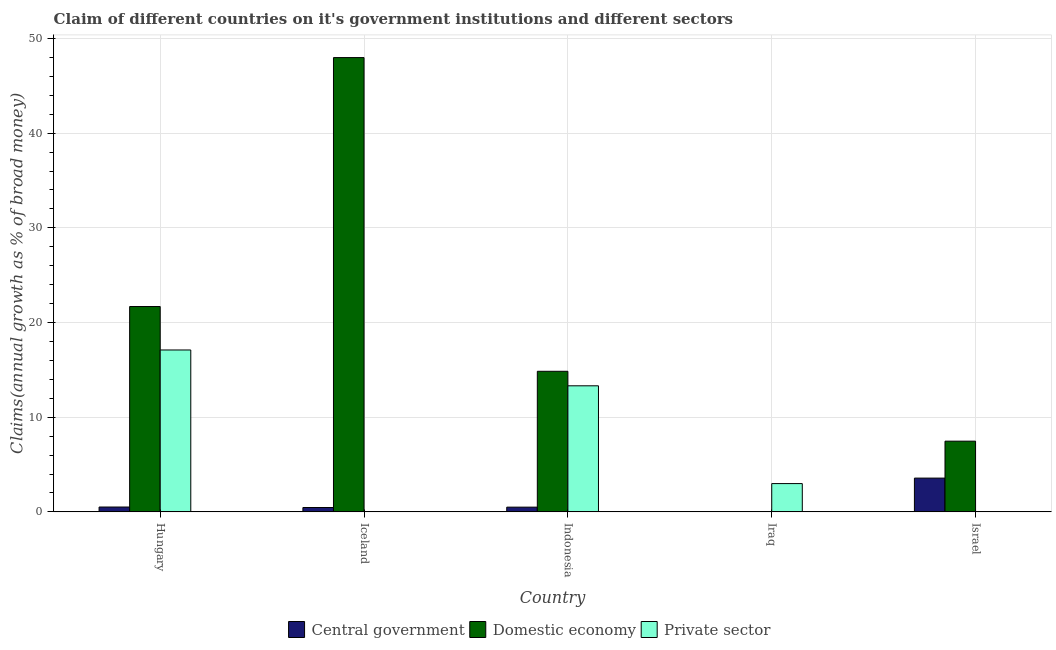How many different coloured bars are there?
Your response must be concise. 3. How many bars are there on the 1st tick from the left?
Your response must be concise. 3. How many bars are there on the 5th tick from the right?
Make the answer very short. 3. What is the label of the 1st group of bars from the left?
Make the answer very short. Hungary. What is the percentage of claim on the private sector in Israel?
Keep it short and to the point. 0. Across all countries, what is the maximum percentage of claim on the domestic economy?
Your answer should be very brief. 47.98. What is the total percentage of claim on the private sector in the graph?
Offer a very short reply. 33.4. What is the difference between the percentage of claim on the private sector in Hungary and that in Iraq?
Your answer should be compact. 14.11. What is the difference between the percentage of claim on the central government in Israel and the percentage of claim on the private sector in Iraq?
Offer a terse response. 0.58. What is the average percentage of claim on the central government per country?
Keep it short and to the point. 1.01. What is the difference between the percentage of claim on the private sector and percentage of claim on the central government in Indonesia?
Your response must be concise. 12.82. What is the ratio of the percentage of claim on the private sector in Indonesia to that in Iraq?
Make the answer very short. 4.46. What is the difference between the highest and the second highest percentage of claim on the central government?
Your response must be concise. 3.05. What is the difference between the highest and the lowest percentage of claim on the domestic economy?
Provide a succinct answer. 47.98. Is it the case that in every country, the sum of the percentage of claim on the central government and percentage of claim on the domestic economy is greater than the percentage of claim on the private sector?
Make the answer very short. No. How many bars are there?
Make the answer very short. 11. What is the difference between two consecutive major ticks on the Y-axis?
Offer a terse response. 10. Does the graph contain any zero values?
Offer a very short reply. Yes. Does the graph contain grids?
Make the answer very short. Yes. Where does the legend appear in the graph?
Offer a terse response. Bottom center. How many legend labels are there?
Provide a succinct answer. 3. What is the title of the graph?
Offer a terse response. Claim of different countries on it's government institutions and different sectors. What is the label or title of the Y-axis?
Provide a succinct answer. Claims(annual growth as % of broad money). What is the Claims(annual growth as % of broad money) in Central government in Hungary?
Offer a very short reply. 0.51. What is the Claims(annual growth as % of broad money) in Domestic economy in Hungary?
Your answer should be very brief. 21.69. What is the Claims(annual growth as % of broad money) in Private sector in Hungary?
Offer a terse response. 17.1. What is the Claims(annual growth as % of broad money) in Central government in Iceland?
Keep it short and to the point. 0.46. What is the Claims(annual growth as % of broad money) in Domestic economy in Iceland?
Your response must be concise. 47.98. What is the Claims(annual growth as % of broad money) in Central government in Indonesia?
Your answer should be compact. 0.5. What is the Claims(annual growth as % of broad money) in Domestic economy in Indonesia?
Your response must be concise. 14.85. What is the Claims(annual growth as % of broad money) of Private sector in Indonesia?
Offer a very short reply. 13.32. What is the Claims(annual growth as % of broad money) of Central government in Iraq?
Provide a succinct answer. 0. What is the Claims(annual growth as % of broad money) in Domestic economy in Iraq?
Make the answer very short. 0. What is the Claims(annual growth as % of broad money) in Private sector in Iraq?
Offer a terse response. 2.99. What is the Claims(annual growth as % of broad money) in Central government in Israel?
Offer a very short reply. 3.57. What is the Claims(annual growth as % of broad money) in Domestic economy in Israel?
Offer a terse response. 7.47. Across all countries, what is the maximum Claims(annual growth as % of broad money) in Central government?
Offer a very short reply. 3.57. Across all countries, what is the maximum Claims(annual growth as % of broad money) in Domestic economy?
Offer a terse response. 47.98. Across all countries, what is the maximum Claims(annual growth as % of broad money) in Private sector?
Provide a succinct answer. 17.1. Across all countries, what is the minimum Claims(annual growth as % of broad money) of Central government?
Provide a short and direct response. 0. What is the total Claims(annual growth as % of broad money) of Central government in the graph?
Offer a terse response. 5.04. What is the total Claims(annual growth as % of broad money) of Domestic economy in the graph?
Provide a succinct answer. 91.99. What is the total Claims(annual growth as % of broad money) in Private sector in the graph?
Ensure brevity in your answer.  33.4. What is the difference between the Claims(annual growth as % of broad money) in Central government in Hungary and that in Iceland?
Make the answer very short. 0.05. What is the difference between the Claims(annual growth as % of broad money) of Domestic economy in Hungary and that in Iceland?
Your answer should be compact. -26.29. What is the difference between the Claims(annual growth as % of broad money) in Central government in Hungary and that in Indonesia?
Provide a short and direct response. 0.01. What is the difference between the Claims(annual growth as % of broad money) in Domestic economy in Hungary and that in Indonesia?
Your answer should be compact. 6.84. What is the difference between the Claims(annual growth as % of broad money) in Private sector in Hungary and that in Indonesia?
Keep it short and to the point. 3.78. What is the difference between the Claims(annual growth as % of broad money) of Private sector in Hungary and that in Iraq?
Your answer should be very brief. 14.11. What is the difference between the Claims(annual growth as % of broad money) in Central government in Hungary and that in Israel?
Ensure brevity in your answer.  -3.05. What is the difference between the Claims(annual growth as % of broad money) in Domestic economy in Hungary and that in Israel?
Make the answer very short. 14.22. What is the difference between the Claims(annual growth as % of broad money) of Central government in Iceland and that in Indonesia?
Your answer should be very brief. -0.04. What is the difference between the Claims(annual growth as % of broad money) of Domestic economy in Iceland and that in Indonesia?
Make the answer very short. 33.13. What is the difference between the Claims(annual growth as % of broad money) in Central government in Iceland and that in Israel?
Offer a very short reply. -3.11. What is the difference between the Claims(annual growth as % of broad money) in Domestic economy in Iceland and that in Israel?
Make the answer very short. 40.51. What is the difference between the Claims(annual growth as % of broad money) in Private sector in Indonesia and that in Iraq?
Give a very brief answer. 10.33. What is the difference between the Claims(annual growth as % of broad money) in Central government in Indonesia and that in Israel?
Ensure brevity in your answer.  -3.07. What is the difference between the Claims(annual growth as % of broad money) in Domestic economy in Indonesia and that in Israel?
Give a very brief answer. 7.38. What is the difference between the Claims(annual growth as % of broad money) of Central government in Hungary and the Claims(annual growth as % of broad money) of Domestic economy in Iceland?
Provide a short and direct response. -47.47. What is the difference between the Claims(annual growth as % of broad money) in Central government in Hungary and the Claims(annual growth as % of broad money) in Domestic economy in Indonesia?
Offer a very short reply. -14.34. What is the difference between the Claims(annual growth as % of broad money) in Central government in Hungary and the Claims(annual growth as % of broad money) in Private sector in Indonesia?
Give a very brief answer. -12.8. What is the difference between the Claims(annual growth as % of broad money) of Domestic economy in Hungary and the Claims(annual growth as % of broad money) of Private sector in Indonesia?
Provide a succinct answer. 8.37. What is the difference between the Claims(annual growth as % of broad money) in Central government in Hungary and the Claims(annual growth as % of broad money) in Private sector in Iraq?
Offer a terse response. -2.48. What is the difference between the Claims(annual growth as % of broad money) in Domestic economy in Hungary and the Claims(annual growth as % of broad money) in Private sector in Iraq?
Ensure brevity in your answer.  18.7. What is the difference between the Claims(annual growth as % of broad money) of Central government in Hungary and the Claims(annual growth as % of broad money) of Domestic economy in Israel?
Ensure brevity in your answer.  -6.96. What is the difference between the Claims(annual growth as % of broad money) of Central government in Iceland and the Claims(annual growth as % of broad money) of Domestic economy in Indonesia?
Your answer should be very brief. -14.39. What is the difference between the Claims(annual growth as % of broad money) in Central government in Iceland and the Claims(annual growth as % of broad money) in Private sector in Indonesia?
Make the answer very short. -12.86. What is the difference between the Claims(annual growth as % of broad money) of Domestic economy in Iceland and the Claims(annual growth as % of broad money) of Private sector in Indonesia?
Your answer should be compact. 34.66. What is the difference between the Claims(annual growth as % of broad money) in Central government in Iceland and the Claims(annual growth as % of broad money) in Private sector in Iraq?
Provide a succinct answer. -2.53. What is the difference between the Claims(annual growth as % of broad money) of Domestic economy in Iceland and the Claims(annual growth as % of broad money) of Private sector in Iraq?
Give a very brief answer. 44.99. What is the difference between the Claims(annual growth as % of broad money) of Central government in Iceland and the Claims(annual growth as % of broad money) of Domestic economy in Israel?
Provide a succinct answer. -7.01. What is the difference between the Claims(annual growth as % of broad money) in Central government in Indonesia and the Claims(annual growth as % of broad money) in Private sector in Iraq?
Keep it short and to the point. -2.49. What is the difference between the Claims(annual growth as % of broad money) of Domestic economy in Indonesia and the Claims(annual growth as % of broad money) of Private sector in Iraq?
Make the answer very short. 11.86. What is the difference between the Claims(annual growth as % of broad money) in Central government in Indonesia and the Claims(annual growth as % of broad money) in Domestic economy in Israel?
Provide a short and direct response. -6.97. What is the average Claims(annual growth as % of broad money) in Central government per country?
Make the answer very short. 1.01. What is the average Claims(annual growth as % of broad money) of Domestic economy per country?
Give a very brief answer. 18.4. What is the average Claims(annual growth as % of broad money) in Private sector per country?
Provide a succinct answer. 6.68. What is the difference between the Claims(annual growth as % of broad money) in Central government and Claims(annual growth as % of broad money) in Domestic economy in Hungary?
Provide a short and direct response. -21.18. What is the difference between the Claims(annual growth as % of broad money) of Central government and Claims(annual growth as % of broad money) of Private sector in Hungary?
Your answer should be very brief. -16.59. What is the difference between the Claims(annual growth as % of broad money) in Domestic economy and Claims(annual growth as % of broad money) in Private sector in Hungary?
Offer a terse response. 4.59. What is the difference between the Claims(annual growth as % of broad money) in Central government and Claims(annual growth as % of broad money) in Domestic economy in Iceland?
Ensure brevity in your answer.  -47.52. What is the difference between the Claims(annual growth as % of broad money) in Central government and Claims(annual growth as % of broad money) in Domestic economy in Indonesia?
Provide a short and direct response. -14.35. What is the difference between the Claims(annual growth as % of broad money) in Central government and Claims(annual growth as % of broad money) in Private sector in Indonesia?
Provide a short and direct response. -12.82. What is the difference between the Claims(annual growth as % of broad money) in Domestic economy and Claims(annual growth as % of broad money) in Private sector in Indonesia?
Provide a short and direct response. 1.53. What is the difference between the Claims(annual growth as % of broad money) in Central government and Claims(annual growth as % of broad money) in Domestic economy in Israel?
Your answer should be compact. -3.9. What is the ratio of the Claims(annual growth as % of broad money) in Central government in Hungary to that in Iceland?
Offer a very short reply. 1.11. What is the ratio of the Claims(annual growth as % of broad money) of Domestic economy in Hungary to that in Iceland?
Your answer should be very brief. 0.45. What is the ratio of the Claims(annual growth as % of broad money) in Central government in Hungary to that in Indonesia?
Offer a very short reply. 1.02. What is the ratio of the Claims(annual growth as % of broad money) of Domestic economy in Hungary to that in Indonesia?
Keep it short and to the point. 1.46. What is the ratio of the Claims(annual growth as % of broad money) in Private sector in Hungary to that in Indonesia?
Provide a short and direct response. 1.28. What is the ratio of the Claims(annual growth as % of broad money) of Private sector in Hungary to that in Iraq?
Your answer should be very brief. 5.72. What is the ratio of the Claims(annual growth as % of broad money) in Central government in Hungary to that in Israel?
Your answer should be very brief. 0.14. What is the ratio of the Claims(annual growth as % of broad money) of Domestic economy in Hungary to that in Israel?
Offer a terse response. 2.9. What is the ratio of the Claims(annual growth as % of broad money) in Central government in Iceland to that in Indonesia?
Make the answer very short. 0.92. What is the ratio of the Claims(annual growth as % of broad money) in Domestic economy in Iceland to that in Indonesia?
Your answer should be very brief. 3.23. What is the ratio of the Claims(annual growth as % of broad money) in Central government in Iceland to that in Israel?
Your answer should be compact. 0.13. What is the ratio of the Claims(annual growth as % of broad money) of Domestic economy in Iceland to that in Israel?
Keep it short and to the point. 6.42. What is the ratio of the Claims(annual growth as % of broad money) in Private sector in Indonesia to that in Iraq?
Provide a short and direct response. 4.46. What is the ratio of the Claims(annual growth as % of broad money) in Central government in Indonesia to that in Israel?
Give a very brief answer. 0.14. What is the ratio of the Claims(annual growth as % of broad money) in Domestic economy in Indonesia to that in Israel?
Keep it short and to the point. 1.99. What is the difference between the highest and the second highest Claims(annual growth as % of broad money) in Central government?
Offer a very short reply. 3.05. What is the difference between the highest and the second highest Claims(annual growth as % of broad money) of Domestic economy?
Your answer should be compact. 26.29. What is the difference between the highest and the second highest Claims(annual growth as % of broad money) of Private sector?
Provide a succinct answer. 3.78. What is the difference between the highest and the lowest Claims(annual growth as % of broad money) of Central government?
Keep it short and to the point. 3.57. What is the difference between the highest and the lowest Claims(annual growth as % of broad money) in Domestic economy?
Provide a short and direct response. 47.98. What is the difference between the highest and the lowest Claims(annual growth as % of broad money) in Private sector?
Make the answer very short. 17.1. 